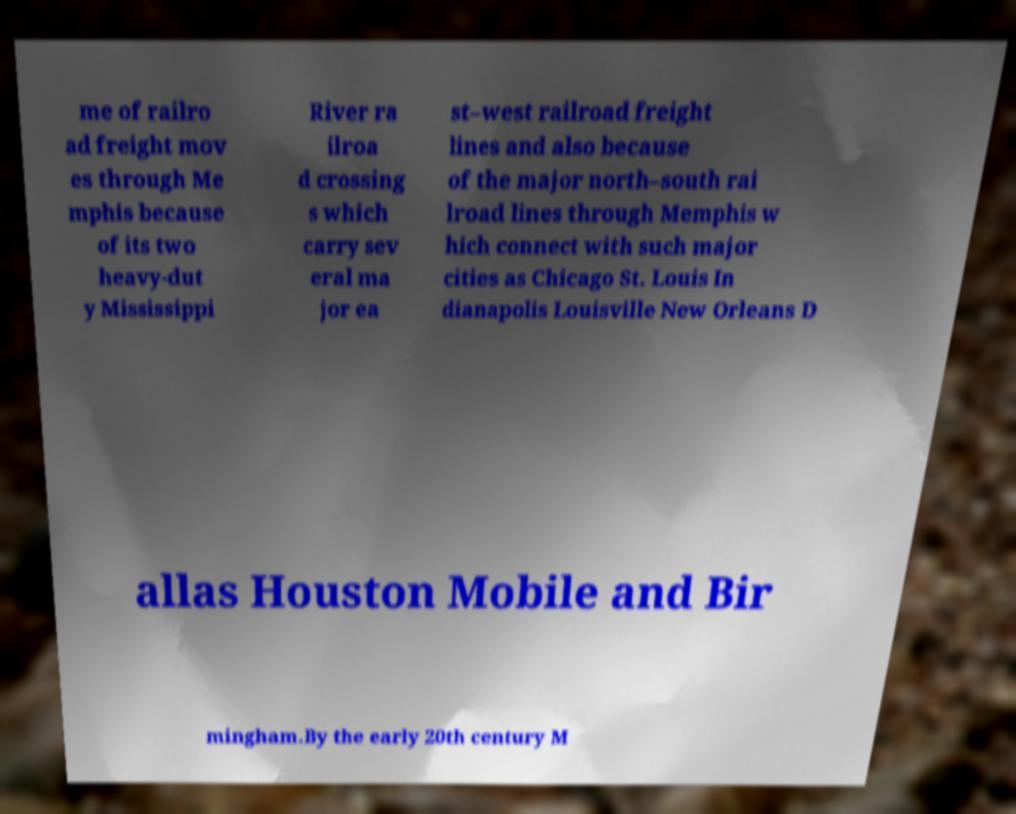Can you read and provide the text displayed in the image?This photo seems to have some interesting text. Can you extract and type it out for me? me of railro ad freight mov es through Me mphis because of its two heavy-dut y Mississippi River ra ilroa d crossing s which carry sev eral ma jor ea st–west railroad freight lines and also because of the major north–south rai lroad lines through Memphis w hich connect with such major cities as Chicago St. Louis In dianapolis Louisville New Orleans D allas Houston Mobile and Bir mingham.By the early 20th century M 